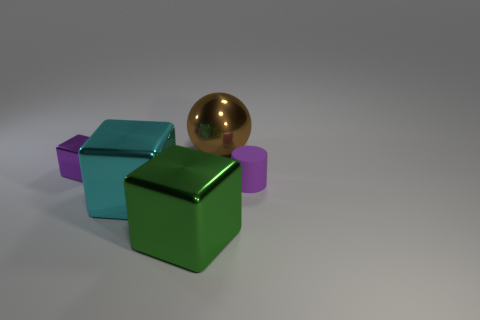Add 3 small things. How many objects exist? 8 Subtract all cylinders. How many objects are left? 4 Add 4 large brown balls. How many large brown balls exist? 5 Subtract 0 blue cylinders. How many objects are left? 5 Subtract all big green metallic objects. Subtract all large cyan metal cylinders. How many objects are left? 4 Add 4 cyan shiny blocks. How many cyan shiny blocks are left? 5 